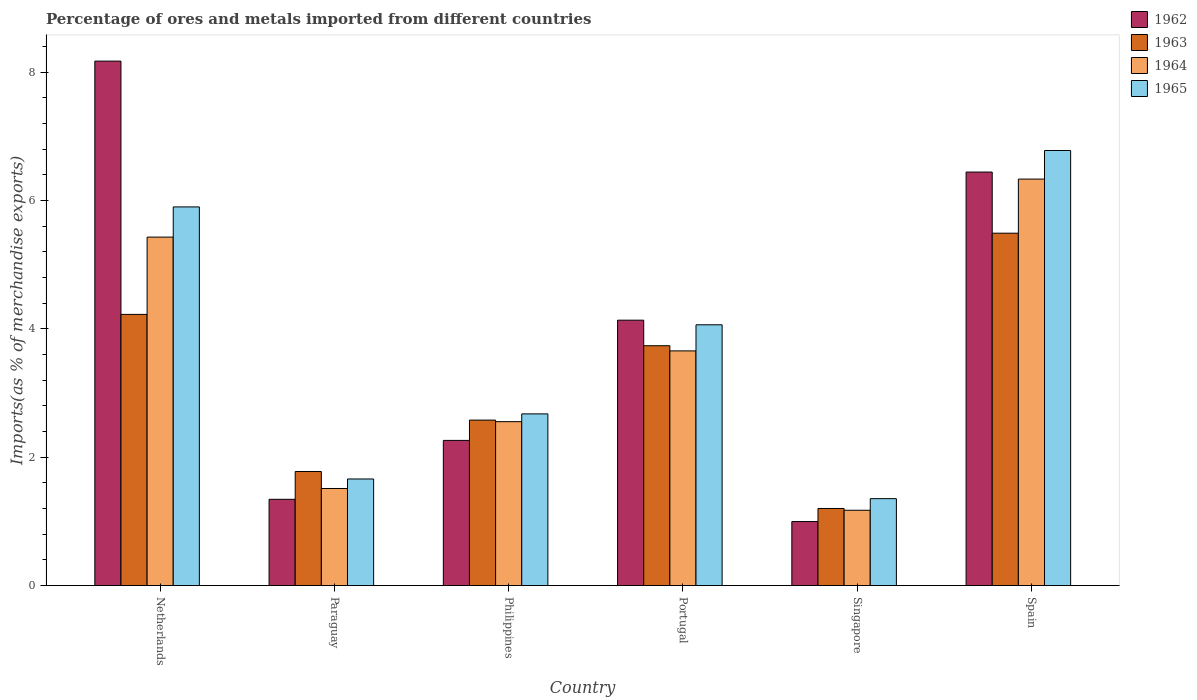How many groups of bars are there?
Make the answer very short. 6. Are the number of bars on each tick of the X-axis equal?
Offer a very short reply. Yes. How many bars are there on the 4th tick from the left?
Give a very brief answer. 4. How many bars are there on the 4th tick from the right?
Provide a succinct answer. 4. What is the percentage of imports to different countries in 1962 in Netherlands?
Make the answer very short. 8.17. Across all countries, what is the maximum percentage of imports to different countries in 1965?
Offer a terse response. 6.78. Across all countries, what is the minimum percentage of imports to different countries in 1962?
Your answer should be compact. 1. In which country was the percentage of imports to different countries in 1962 maximum?
Offer a terse response. Netherlands. In which country was the percentage of imports to different countries in 1963 minimum?
Your answer should be compact. Singapore. What is the total percentage of imports to different countries in 1965 in the graph?
Give a very brief answer. 22.43. What is the difference between the percentage of imports to different countries in 1962 in Netherlands and that in Singapore?
Offer a terse response. 7.17. What is the difference between the percentage of imports to different countries in 1964 in Paraguay and the percentage of imports to different countries in 1962 in Portugal?
Your answer should be compact. -2.62. What is the average percentage of imports to different countries in 1963 per country?
Your response must be concise. 3.17. What is the difference between the percentage of imports to different countries of/in 1962 and percentage of imports to different countries of/in 1963 in Paraguay?
Provide a succinct answer. -0.43. In how many countries, is the percentage of imports to different countries in 1964 greater than 5.6 %?
Your answer should be very brief. 1. What is the ratio of the percentage of imports to different countries in 1964 in Netherlands to that in Singapore?
Offer a terse response. 4.63. Is the percentage of imports to different countries in 1963 in Portugal less than that in Singapore?
Your answer should be compact. No. What is the difference between the highest and the second highest percentage of imports to different countries in 1964?
Ensure brevity in your answer.  -1.77. What is the difference between the highest and the lowest percentage of imports to different countries in 1965?
Ensure brevity in your answer.  5.42. What does the 3rd bar from the left in Netherlands represents?
Your response must be concise. 1964. What does the 2nd bar from the right in Paraguay represents?
Your response must be concise. 1964. What is the difference between two consecutive major ticks on the Y-axis?
Give a very brief answer. 2. Does the graph contain grids?
Keep it short and to the point. No. How many legend labels are there?
Offer a terse response. 4. What is the title of the graph?
Give a very brief answer. Percentage of ores and metals imported from different countries. Does "2000" appear as one of the legend labels in the graph?
Ensure brevity in your answer.  No. What is the label or title of the X-axis?
Your answer should be very brief. Country. What is the label or title of the Y-axis?
Offer a very short reply. Imports(as % of merchandise exports). What is the Imports(as % of merchandise exports) of 1962 in Netherlands?
Give a very brief answer. 8.17. What is the Imports(as % of merchandise exports) in 1963 in Netherlands?
Give a very brief answer. 4.22. What is the Imports(as % of merchandise exports) in 1964 in Netherlands?
Your answer should be compact. 5.43. What is the Imports(as % of merchandise exports) in 1965 in Netherlands?
Provide a succinct answer. 5.9. What is the Imports(as % of merchandise exports) of 1962 in Paraguay?
Give a very brief answer. 1.34. What is the Imports(as % of merchandise exports) in 1963 in Paraguay?
Give a very brief answer. 1.78. What is the Imports(as % of merchandise exports) in 1964 in Paraguay?
Your response must be concise. 1.51. What is the Imports(as % of merchandise exports) of 1965 in Paraguay?
Provide a short and direct response. 1.66. What is the Imports(as % of merchandise exports) in 1962 in Philippines?
Your response must be concise. 2.26. What is the Imports(as % of merchandise exports) of 1963 in Philippines?
Your answer should be very brief. 2.58. What is the Imports(as % of merchandise exports) in 1964 in Philippines?
Provide a short and direct response. 2.55. What is the Imports(as % of merchandise exports) of 1965 in Philippines?
Make the answer very short. 2.67. What is the Imports(as % of merchandise exports) of 1962 in Portugal?
Make the answer very short. 4.13. What is the Imports(as % of merchandise exports) of 1963 in Portugal?
Ensure brevity in your answer.  3.74. What is the Imports(as % of merchandise exports) in 1964 in Portugal?
Ensure brevity in your answer.  3.66. What is the Imports(as % of merchandise exports) in 1965 in Portugal?
Provide a short and direct response. 4.06. What is the Imports(as % of merchandise exports) in 1962 in Singapore?
Offer a terse response. 1. What is the Imports(as % of merchandise exports) of 1963 in Singapore?
Provide a succinct answer. 1.2. What is the Imports(as % of merchandise exports) in 1964 in Singapore?
Give a very brief answer. 1.17. What is the Imports(as % of merchandise exports) of 1965 in Singapore?
Provide a succinct answer. 1.35. What is the Imports(as % of merchandise exports) of 1962 in Spain?
Keep it short and to the point. 6.44. What is the Imports(as % of merchandise exports) in 1963 in Spain?
Make the answer very short. 5.49. What is the Imports(as % of merchandise exports) of 1964 in Spain?
Offer a terse response. 6.33. What is the Imports(as % of merchandise exports) in 1965 in Spain?
Your answer should be very brief. 6.78. Across all countries, what is the maximum Imports(as % of merchandise exports) in 1962?
Your answer should be compact. 8.17. Across all countries, what is the maximum Imports(as % of merchandise exports) in 1963?
Keep it short and to the point. 5.49. Across all countries, what is the maximum Imports(as % of merchandise exports) of 1964?
Your response must be concise. 6.33. Across all countries, what is the maximum Imports(as % of merchandise exports) of 1965?
Ensure brevity in your answer.  6.78. Across all countries, what is the minimum Imports(as % of merchandise exports) in 1962?
Provide a succinct answer. 1. Across all countries, what is the minimum Imports(as % of merchandise exports) in 1963?
Your response must be concise. 1.2. Across all countries, what is the minimum Imports(as % of merchandise exports) of 1964?
Make the answer very short. 1.17. Across all countries, what is the minimum Imports(as % of merchandise exports) in 1965?
Your answer should be compact. 1.35. What is the total Imports(as % of merchandise exports) in 1962 in the graph?
Ensure brevity in your answer.  23.35. What is the total Imports(as % of merchandise exports) of 1963 in the graph?
Your answer should be very brief. 19.01. What is the total Imports(as % of merchandise exports) of 1964 in the graph?
Your response must be concise. 20.66. What is the total Imports(as % of merchandise exports) of 1965 in the graph?
Make the answer very short. 22.43. What is the difference between the Imports(as % of merchandise exports) of 1962 in Netherlands and that in Paraguay?
Offer a very short reply. 6.83. What is the difference between the Imports(as % of merchandise exports) in 1963 in Netherlands and that in Paraguay?
Your answer should be compact. 2.45. What is the difference between the Imports(as % of merchandise exports) of 1964 in Netherlands and that in Paraguay?
Your response must be concise. 3.92. What is the difference between the Imports(as % of merchandise exports) in 1965 in Netherlands and that in Paraguay?
Your answer should be compact. 4.24. What is the difference between the Imports(as % of merchandise exports) in 1962 in Netherlands and that in Philippines?
Make the answer very short. 5.91. What is the difference between the Imports(as % of merchandise exports) in 1963 in Netherlands and that in Philippines?
Offer a terse response. 1.65. What is the difference between the Imports(as % of merchandise exports) in 1964 in Netherlands and that in Philippines?
Ensure brevity in your answer.  2.88. What is the difference between the Imports(as % of merchandise exports) of 1965 in Netherlands and that in Philippines?
Your response must be concise. 3.22. What is the difference between the Imports(as % of merchandise exports) in 1962 in Netherlands and that in Portugal?
Provide a short and direct response. 4.04. What is the difference between the Imports(as % of merchandise exports) in 1963 in Netherlands and that in Portugal?
Provide a succinct answer. 0.49. What is the difference between the Imports(as % of merchandise exports) of 1964 in Netherlands and that in Portugal?
Offer a terse response. 1.77. What is the difference between the Imports(as % of merchandise exports) in 1965 in Netherlands and that in Portugal?
Your response must be concise. 1.84. What is the difference between the Imports(as % of merchandise exports) in 1962 in Netherlands and that in Singapore?
Give a very brief answer. 7.17. What is the difference between the Imports(as % of merchandise exports) of 1963 in Netherlands and that in Singapore?
Give a very brief answer. 3.02. What is the difference between the Imports(as % of merchandise exports) in 1964 in Netherlands and that in Singapore?
Provide a succinct answer. 4.26. What is the difference between the Imports(as % of merchandise exports) of 1965 in Netherlands and that in Singapore?
Your response must be concise. 4.55. What is the difference between the Imports(as % of merchandise exports) in 1962 in Netherlands and that in Spain?
Your answer should be compact. 1.73. What is the difference between the Imports(as % of merchandise exports) of 1963 in Netherlands and that in Spain?
Provide a succinct answer. -1.27. What is the difference between the Imports(as % of merchandise exports) of 1964 in Netherlands and that in Spain?
Your answer should be compact. -0.9. What is the difference between the Imports(as % of merchandise exports) of 1965 in Netherlands and that in Spain?
Provide a short and direct response. -0.88. What is the difference between the Imports(as % of merchandise exports) in 1962 in Paraguay and that in Philippines?
Give a very brief answer. -0.92. What is the difference between the Imports(as % of merchandise exports) in 1963 in Paraguay and that in Philippines?
Your answer should be very brief. -0.8. What is the difference between the Imports(as % of merchandise exports) of 1964 in Paraguay and that in Philippines?
Your answer should be very brief. -1.04. What is the difference between the Imports(as % of merchandise exports) in 1965 in Paraguay and that in Philippines?
Your answer should be very brief. -1.01. What is the difference between the Imports(as % of merchandise exports) of 1962 in Paraguay and that in Portugal?
Provide a short and direct response. -2.79. What is the difference between the Imports(as % of merchandise exports) in 1963 in Paraguay and that in Portugal?
Make the answer very short. -1.96. What is the difference between the Imports(as % of merchandise exports) in 1964 in Paraguay and that in Portugal?
Provide a succinct answer. -2.14. What is the difference between the Imports(as % of merchandise exports) of 1965 in Paraguay and that in Portugal?
Your answer should be compact. -2.4. What is the difference between the Imports(as % of merchandise exports) in 1962 in Paraguay and that in Singapore?
Keep it short and to the point. 0.35. What is the difference between the Imports(as % of merchandise exports) in 1963 in Paraguay and that in Singapore?
Make the answer very short. 0.58. What is the difference between the Imports(as % of merchandise exports) of 1964 in Paraguay and that in Singapore?
Provide a short and direct response. 0.34. What is the difference between the Imports(as % of merchandise exports) of 1965 in Paraguay and that in Singapore?
Give a very brief answer. 0.31. What is the difference between the Imports(as % of merchandise exports) of 1962 in Paraguay and that in Spain?
Provide a succinct answer. -5.1. What is the difference between the Imports(as % of merchandise exports) of 1963 in Paraguay and that in Spain?
Provide a short and direct response. -3.71. What is the difference between the Imports(as % of merchandise exports) of 1964 in Paraguay and that in Spain?
Offer a terse response. -4.82. What is the difference between the Imports(as % of merchandise exports) in 1965 in Paraguay and that in Spain?
Provide a succinct answer. -5.12. What is the difference between the Imports(as % of merchandise exports) in 1962 in Philippines and that in Portugal?
Keep it short and to the point. -1.87. What is the difference between the Imports(as % of merchandise exports) of 1963 in Philippines and that in Portugal?
Provide a short and direct response. -1.16. What is the difference between the Imports(as % of merchandise exports) in 1964 in Philippines and that in Portugal?
Offer a terse response. -1.1. What is the difference between the Imports(as % of merchandise exports) in 1965 in Philippines and that in Portugal?
Offer a very short reply. -1.39. What is the difference between the Imports(as % of merchandise exports) in 1962 in Philippines and that in Singapore?
Offer a terse response. 1.26. What is the difference between the Imports(as % of merchandise exports) in 1963 in Philippines and that in Singapore?
Make the answer very short. 1.38. What is the difference between the Imports(as % of merchandise exports) in 1964 in Philippines and that in Singapore?
Your answer should be compact. 1.38. What is the difference between the Imports(as % of merchandise exports) of 1965 in Philippines and that in Singapore?
Offer a very short reply. 1.32. What is the difference between the Imports(as % of merchandise exports) of 1962 in Philippines and that in Spain?
Your answer should be very brief. -4.18. What is the difference between the Imports(as % of merchandise exports) of 1963 in Philippines and that in Spain?
Provide a succinct answer. -2.91. What is the difference between the Imports(as % of merchandise exports) of 1964 in Philippines and that in Spain?
Give a very brief answer. -3.78. What is the difference between the Imports(as % of merchandise exports) of 1965 in Philippines and that in Spain?
Provide a short and direct response. -4.1. What is the difference between the Imports(as % of merchandise exports) of 1962 in Portugal and that in Singapore?
Your answer should be very brief. 3.14. What is the difference between the Imports(as % of merchandise exports) of 1963 in Portugal and that in Singapore?
Offer a terse response. 2.54. What is the difference between the Imports(as % of merchandise exports) of 1964 in Portugal and that in Singapore?
Provide a succinct answer. 2.48. What is the difference between the Imports(as % of merchandise exports) in 1965 in Portugal and that in Singapore?
Offer a terse response. 2.71. What is the difference between the Imports(as % of merchandise exports) of 1962 in Portugal and that in Spain?
Offer a terse response. -2.31. What is the difference between the Imports(as % of merchandise exports) of 1963 in Portugal and that in Spain?
Your response must be concise. -1.75. What is the difference between the Imports(as % of merchandise exports) in 1964 in Portugal and that in Spain?
Provide a succinct answer. -2.68. What is the difference between the Imports(as % of merchandise exports) of 1965 in Portugal and that in Spain?
Ensure brevity in your answer.  -2.72. What is the difference between the Imports(as % of merchandise exports) in 1962 in Singapore and that in Spain?
Your answer should be compact. -5.45. What is the difference between the Imports(as % of merchandise exports) of 1963 in Singapore and that in Spain?
Your response must be concise. -4.29. What is the difference between the Imports(as % of merchandise exports) of 1964 in Singapore and that in Spain?
Give a very brief answer. -5.16. What is the difference between the Imports(as % of merchandise exports) of 1965 in Singapore and that in Spain?
Your answer should be compact. -5.42. What is the difference between the Imports(as % of merchandise exports) of 1962 in Netherlands and the Imports(as % of merchandise exports) of 1963 in Paraguay?
Your answer should be very brief. 6.39. What is the difference between the Imports(as % of merchandise exports) in 1962 in Netherlands and the Imports(as % of merchandise exports) in 1964 in Paraguay?
Make the answer very short. 6.66. What is the difference between the Imports(as % of merchandise exports) in 1962 in Netherlands and the Imports(as % of merchandise exports) in 1965 in Paraguay?
Provide a short and direct response. 6.51. What is the difference between the Imports(as % of merchandise exports) of 1963 in Netherlands and the Imports(as % of merchandise exports) of 1964 in Paraguay?
Your answer should be very brief. 2.71. What is the difference between the Imports(as % of merchandise exports) in 1963 in Netherlands and the Imports(as % of merchandise exports) in 1965 in Paraguay?
Make the answer very short. 2.56. What is the difference between the Imports(as % of merchandise exports) of 1964 in Netherlands and the Imports(as % of merchandise exports) of 1965 in Paraguay?
Keep it short and to the point. 3.77. What is the difference between the Imports(as % of merchandise exports) of 1962 in Netherlands and the Imports(as % of merchandise exports) of 1963 in Philippines?
Keep it short and to the point. 5.59. What is the difference between the Imports(as % of merchandise exports) of 1962 in Netherlands and the Imports(as % of merchandise exports) of 1964 in Philippines?
Your response must be concise. 5.62. What is the difference between the Imports(as % of merchandise exports) of 1962 in Netherlands and the Imports(as % of merchandise exports) of 1965 in Philippines?
Offer a terse response. 5.5. What is the difference between the Imports(as % of merchandise exports) of 1963 in Netherlands and the Imports(as % of merchandise exports) of 1964 in Philippines?
Provide a short and direct response. 1.67. What is the difference between the Imports(as % of merchandise exports) in 1963 in Netherlands and the Imports(as % of merchandise exports) in 1965 in Philippines?
Your answer should be compact. 1.55. What is the difference between the Imports(as % of merchandise exports) of 1964 in Netherlands and the Imports(as % of merchandise exports) of 1965 in Philippines?
Provide a short and direct response. 2.75. What is the difference between the Imports(as % of merchandise exports) of 1962 in Netherlands and the Imports(as % of merchandise exports) of 1963 in Portugal?
Your answer should be compact. 4.43. What is the difference between the Imports(as % of merchandise exports) of 1962 in Netherlands and the Imports(as % of merchandise exports) of 1964 in Portugal?
Provide a succinct answer. 4.51. What is the difference between the Imports(as % of merchandise exports) in 1962 in Netherlands and the Imports(as % of merchandise exports) in 1965 in Portugal?
Make the answer very short. 4.11. What is the difference between the Imports(as % of merchandise exports) of 1963 in Netherlands and the Imports(as % of merchandise exports) of 1964 in Portugal?
Offer a terse response. 0.57. What is the difference between the Imports(as % of merchandise exports) in 1963 in Netherlands and the Imports(as % of merchandise exports) in 1965 in Portugal?
Offer a terse response. 0.16. What is the difference between the Imports(as % of merchandise exports) of 1964 in Netherlands and the Imports(as % of merchandise exports) of 1965 in Portugal?
Your answer should be very brief. 1.37. What is the difference between the Imports(as % of merchandise exports) in 1962 in Netherlands and the Imports(as % of merchandise exports) in 1963 in Singapore?
Your response must be concise. 6.97. What is the difference between the Imports(as % of merchandise exports) of 1962 in Netherlands and the Imports(as % of merchandise exports) of 1964 in Singapore?
Make the answer very short. 7. What is the difference between the Imports(as % of merchandise exports) in 1962 in Netherlands and the Imports(as % of merchandise exports) in 1965 in Singapore?
Your answer should be compact. 6.82. What is the difference between the Imports(as % of merchandise exports) of 1963 in Netherlands and the Imports(as % of merchandise exports) of 1964 in Singapore?
Your response must be concise. 3.05. What is the difference between the Imports(as % of merchandise exports) of 1963 in Netherlands and the Imports(as % of merchandise exports) of 1965 in Singapore?
Your answer should be compact. 2.87. What is the difference between the Imports(as % of merchandise exports) in 1964 in Netherlands and the Imports(as % of merchandise exports) in 1965 in Singapore?
Provide a short and direct response. 4.07. What is the difference between the Imports(as % of merchandise exports) in 1962 in Netherlands and the Imports(as % of merchandise exports) in 1963 in Spain?
Your answer should be compact. 2.68. What is the difference between the Imports(as % of merchandise exports) in 1962 in Netherlands and the Imports(as % of merchandise exports) in 1964 in Spain?
Your response must be concise. 1.84. What is the difference between the Imports(as % of merchandise exports) in 1962 in Netherlands and the Imports(as % of merchandise exports) in 1965 in Spain?
Give a very brief answer. 1.39. What is the difference between the Imports(as % of merchandise exports) in 1963 in Netherlands and the Imports(as % of merchandise exports) in 1964 in Spain?
Your answer should be compact. -2.11. What is the difference between the Imports(as % of merchandise exports) in 1963 in Netherlands and the Imports(as % of merchandise exports) in 1965 in Spain?
Make the answer very short. -2.55. What is the difference between the Imports(as % of merchandise exports) in 1964 in Netherlands and the Imports(as % of merchandise exports) in 1965 in Spain?
Provide a short and direct response. -1.35. What is the difference between the Imports(as % of merchandise exports) in 1962 in Paraguay and the Imports(as % of merchandise exports) in 1963 in Philippines?
Your response must be concise. -1.23. What is the difference between the Imports(as % of merchandise exports) of 1962 in Paraguay and the Imports(as % of merchandise exports) of 1964 in Philippines?
Your answer should be compact. -1.21. What is the difference between the Imports(as % of merchandise exports) of 1962 in Paraguay and the Imports(as % of merchandise exports) of 1965 in Philippines?
Make the answer very short. -1.33. What is the difference between the Imports(as % of merchandise exports) in 1963 in Paraguay and the Imports(as % of merchandise exports) in 1964 in Philippines?
Provide a succinct answer. -0.78. What is the difference between the Imports(as % of merchandise exports) in 1963 in Paraguay and the Imports(as % of merchandise exports) in 1965 in Philippines?
Ensure brevity in your answer.  -0.9. What is the difference between the Imports(as % of merchandise exports) in 1964 in Paraguay and the Imports(as % of merchandise exports) in 1965 in Philippines?
Keep it short and to the point. -1.16. What is the difference between the Imports(as % of merchandise exports) in 1962 in Paraguay and the Imports(as % of merchandise exports) in 1963 in Portugal?
Your response must be concise. -2.39. What is the difference between the Imports(as % of merchandise exports) of 1962 in Paraguay and the Imports(as % of merchandise exports) of 1964 in Portugal?
Ensure brevity in your answer.  -2.31. What is the difference between the Imports(as % of merchandise exports) in 1962 in Paraguay and the Imports(as % of merchandise exports) in 1965 in Portugal?
Provide a short and direct response. -2.72. What is the difference between the Imports(as % of merchandise exports) of 1963 in Paraguay and the Imports(as % of merchandise exports) of 1964 in Portugal?
Your answer should be compact. -1.88. What is the difference between the Imports(as % of merchandise exports) of 1963 in Paraguay and the Imports(as % of merchandise exports) of 1965 in Portugal?
Provide a short and direct response. -2.29. What is the difference between the Imports(as % of merchandise exports) of 1964 in Paraguay and the Imports(as % of merchandise exports) of 1965 in Portugal?
Your answer should be very brief. -2.55. What is the difference between the Imports(as % of merchandise exports) of 1962 in Paraguay and the Imports(as % of merchandise exports) of 1963 in Singapore?
Your response must be concise. 0.14. What is the difference between the Imports(as % of merchandise exports) in 1962 in Paraguay and the Imports(as % of merchandise exports) in 1964 in Singapore?
Your answer should be compact. 0.17. What is the difference between the Imports(as % of merchandise exports) of 1962 in Paraguay and the Imports(as % of merchandise exports) of 1965 in Singapore?
Make the answer very short. -0.01. What is the difference between the Imports(as % of merchandise exports) of 1963 in Paraguay and the Imports(as % of merchandise exports) of 1964 in Singapore?
Offer a very short reply. 0.6. What is the difference between the Imports(as % of merchandise exports) of 1963 in Paraguay and the Imports(as % of merchandise exports) of 1965 in Singapore?
Offer a terse response. 0.42. What is the difference between the Imports(as % of merchandise exports) in 1964 in Paraguay and the Imports(as % of merchandise exports) in 1965 in Singapore?
Your answer should be very brief. 0.16. What is the difference between the Imports(as % of merchandise exports) in 1962 in Paraguay and the Imports(as % of merchandise exports) in 1963 in Spain?
Keep it short and to the point. -4.15. What is the difference between the Imports(as % of merchandise exports) of 1962 in Paraguay and the Imports(as % of merchandise exports) of 1964 in Spain?
Make the answer very short. -4.99. What is the difference between the Imports(as % of merchandise exports) of 1962 in Paraguay and the Imports(as % of merchandise exports) of 1965 in Spain?
Ensure brevity in your answer.  -5.43. What is the difference between the Imports(as % of merchandise exports) in 1963 in Paraguay and the Imports(as % of merchandise exports) in 1964 in Spain?
Your response must be concise. -4.56. What is the difference between the Imports(as % of merchandise exports) of 1963 in Paraguay and the Imports(as % of merchandise exports) of 1965 in Spain?
Offer a very short reply. -5. What is the difference between the Imports(as % of merchandise exports) of 1964 in Paraguay and the Imports(as % of merchandise exports) of 1965 in Spain?
Your answer should be compact. -5.27. What is the difference between the Imports(as % of merchandise exports) of 1962 in Philippines and the Imports(as % of merchandise exports) of 1963 in Portugal?
Provide a short and direct response. -1.47. What is the difference between the Imports(as % of merchandise exports) in 1962 in Philippines and the Imports(as % of merchandise exports) in 1964 in Portugal?
Provide a short and direct response. -1.39. What is the difference between the Imports(as % of merchandise exports) of 1962 in Philippines and the Imports(as % of merchandise exports) of 1965 in Portugal?
Offer a terse response. -1.8. What is the difference between the Imports(as % of merchandise exports) in 1963 in Philippines and the Imports(as % of merchandise exports) in 1964 in Portugal?
Keep it short and to the point. -1.08. What is the difference between the Imports(as % of merchandise exports) in 1963 in Philippines and the Imports(as % of merchandise exports) in 1965 in Portugal?
Give a very brief answer. -1.48. What is the difference between the Imports(as % of merchandise exports) in 1964 in Philippines and the Imports(as % of merchandise exports) in 1965 in Portugal?
Your response must be concise. -1.51. What is the difference between the Imports(as % of merchandise exports) of 1962 in Philippines and the Imports(as % of merchandise exports) of 1963 in Singapore?
Offer a terse response. 1.06. What is the difference between the Imports(as % of merchandise exports) of 1962 in Philippines and the Imports(as % of merchandise exports) of 1964 in Singapore?
Your answer should be very brief. 1.09. What is the difference between the Imports(as % of merchandise exports) in 1962 in Philippines and the Imports(as % of merchandise exports) in 1965 in Singapore?
Your response must be concise. 0.91. What is the difference between the Imports(as % of merchandise exports) in 1963 in Philippines and the Imports(as % of merchandise exports) in 1964 in Singapore?
Make the answer very short. 1.4. What is the difference between the Imports(as % of merchandise exports) of 1963 in Philippines and the Imports(as % of merchandise exports) of 1965 in Singapore?
Your response must be concise. 1.22. What is the difference between the Imports(as % of merchandise exports) of 1964 in Philippines and the Imports(as % of merchandise exports) of 1965 in Singapore?
Provide a succinct answer. 1.2. What is the difference between the Imports(as % of merchandise exports) in 1962 in Philippines and the Imports(as % of merchandise exports) in 1963 in Spain?
Give a very brief answer. -3.23. What is the difference between the Imports(as % of merchandise exports) in 1962 in Philippines and the Imports(as % of merchandise exports) in 1964 in Spain?
Keep it short and to the point. -4.07. What is the difference between the Imports(as % of merchandise exports) of 1962 in Philippines and the Imports(as % of merchandise exports) of 1965 in Spain?
Make the answer very short. -4.52. What is the difference between the Imports(as % of merchandise exports) in 1963 in Philippines and the Imports(as % of merchandise exports) in 1964 in Spain?
Provide a succinct answer. -3.75. What is the difference between the Imports(as % of merchandise exports) in 1963 in Philippines and the Imports(as % of merchandise exports) in 1965 in Spain?
Ensure brevity in your answer.  -4.2. What is the difference between the Imports(as % of merchandise exports) of 1964 in Philippines and the Imports(as % of merchandise exports) of 1965 in Spain?
Keep it short and to the point. -4.22. What is the difference between the Imports(as % of merchandise exports) in 1962 in Portugal and the Imports(as % of merchandise exports) in 1963 in Singapore?
Provide a succinct answer. 2.93. What is the difference between the Imports(as % of merchandise exports) in 1962 in Portugal and the Imports(as % of merchandise exports) in 1964 in Singapore?
Your answer should be very brief. 2.96. What is the difference between the Imports(as % of merchandise exports) of 1962 in Portugal and the Imports(as % of merchandise exports) of 1965 in Singapore?
Make the answer very short. 2.78. What is the difference between the Imports(as % of merchandise exports) of 1963 in Portugal and the Imports(as % of merchandise exports) of 1964 in Singapore?
Your response must be concise. 2.56. What is the difference between the Imports(as % of merchandise exports) in 1963 in Portugal and the Imports(as % of merchandise exports) in 1965 in Singapore?
Provide a short and direct response. 2.38. What is the difference between the Imports(as % of merchandise exports) in 1964 in Portugal and the Imports(as % of merchandise exports) in 1965 in Singapore?
Offer a very short reply. 2.3. What is the difference between the Imports(as % of merchandise exports) in 1962 in Portugal and the Imports(as % of merchandise exports) in 1963 in Spain?
Provide a short and direct response. -1.36. What is the difference between the Imports(as % of merchandise exports) in 1962 in Portugal and the Imports(as % of merchandise exports) in 1964 in Spain?
Your response must be concise. -2.2. What is the difference between the Imports(as % of merchandise exports) in 1962 in Portugal and the Imports(as % of merchandise exports) in 1965 in Spain?
Your answer should be compact. -2.64. What is the difference between the Imports(as % of merchandise exports) of 1963 in Portugal and the Imports(as % of merchandise exports) of 1964 in Spain?
Your answer should be compact. -2.6. What is the difference between the Imports(as % of merchandise exports) of 1963 in Portugal and the Imports(as % of merchandise exports) of 1965 in Spain?
Make the answer very short. -3.04. What is the difference between the Imports(as % of merchandise exports) of 1964 in Portugal and the Imports(as % of merchandise exports) of 1965 in Spain?
Make the answer very short. -3.12. What is the difference between the Imports(as % of merchandise exports) in 1962 in Singapore and the Imports(as % of merchandise exports) in 1963 in Spain?
Provide a short and direct response. -4.49. What is the difference between the Imports(as % of merchandise exports) in 1962 in Singapore and the Imports(as % of merchandise exports) in 1964 in Spain?
Provide a succinct answer. -5.34. What is the difference between the Imports(as % of merchandise exports) in 1962 in Singapore and the Imports(as % of merchandise exports) in 1965 in Spain?
Keep it short and to the point. -5.78. What is the difference between the Imports(as % of merchandise exports) of 1963 in Singapore and the Imports(as % of merchandise exports) of 1964 in Spain?
Make the answer very short. -5.13. What is the difference between the Imports(as % of merchandise exports) in 1963 in Singapore and the Imports(as % of merchandise exports) in 1965 in Spain?
Give a very brief answer. -5.58. What is the difference between the Imports(as % of merchandise exports) of 1964 in Singapore and the Imports(as % of merchandise exports) of 1965 in Spain?
Your answer should be very brief. -5.61. What is the average Imports(as % of merchandise exports) of 1962 per country?
Make the answer very short. 3.89. What is the average Imports(as % of merchandise exports) in 1963 per country?
Your answer should be very brief. 3.17. What is the average Imports(as % of merchandise exports) of 1964 per country?
Give a very brief answer. 3.44. What is the average Imports(as % of merchandise exports) in 1965 per country?
Your answer should be very brief. 3.74. What is the difference between the Imports(as % of merchandise exports) in 1962 and Imports(as % of merchandise exports) in 1963 in Netherlands?
Make the answer very short. 3.95. What is the difference between the Imports(as % of merchandise exports) of 1962 and Imports(as % of merchandise exports) of 1964 in Netherlands?
Make the answer very short. 2.74. What is the difference between the Imports(as % of merchandise exports) of 1962 and Imports(as % of merchandise exports) of 1965 in Netherlands?
Provide a short and direct response. 2.27. What is the difference between the Imports(as % of merchandise exports) of 1963 and Imports(as % of merchandise exports) of 1964 in Netherlands?
Provide a short and direct response. -1.2. What is the difference between the Imports(as % of merchandise exports) in 1963 and Imports(as % of merchandise exports) in 1965 in Netherlands?
Ensure brevity in your answer.  -1.67. What is the difference between the Imports(as % of merchandise exports) of 1964 and Imports(as % of merchandise exports) of 1965 in Netherlands?
Ensure brevity in your answer.  -0.47. What is the difference between the Imports(as % of merchandise exports) in 1962 and Imports(as % of merchandise exports) in 1963 in Paraguay?
Offer a terse response. -0.43. What is the difference between the Imports(as % of merchandise exports) in 1962 and Imports(as % of merchandise exports) in 1964 in Paraguay?
Ensure brevity in your answer.  -0.17. What is the difference between the Imports(as % of merchandise exports) in 1962 and Imports(as % of merchandise exports) in 1965 in Paraguay?
Offer a very short reply. -0.32. What is the difference between the Imports(as % of merchandise exports) in 1963 and Imports(as % of merchandise exports) in 1964 in Paraguay?
Make the answer very short. 0.26. What is the difference between the Imports(as % of merchandise exports) of 1963 and Imports(as % of merchandise exports) of 1965 in Paraguay?
Offer a very short reply. 0.12. What is the difference between the Imports(as % of merchandise exports) of 1964 and Imports(as % of merchandise exports) of 1965 in Paraguay?
Provide a short and direct response. -0.15. What is the difference between the Imports(as % of merchandise exports) of 1962 and Imports(as % of merchandise exports) of 1963 in Philippines?
Offer a terse response. -0.32. What is the difference between the Imports(as % of merchandise exports) of 1962 and Imports(as % of merchandise exports) of 1964 in Philippines?
Ensure brevity in your answer.  -0.29. What is the difference between the Imports(as % of merchandise exports) of 1962 and Imports(as % of merchandise exports) of 1965 in Philippines?
Give a very brief answer. -0.41. What is the difference between the Imports(as % of merchandise exports) in 1963 and Imports(as % of merchandise exports) in 1964 in Philippines?
Your answer should be compact. 0.02. What is the difference between the Imports(as % of merchandise exports) of 1963 and Imports(as % of merchandise exports) of 1965 in Philippines?
Provide a succinct answer. -0.1. What is the difference between the Imports(as % of merchandise exports) in 1964 and Imports(as % of merchandise exports) in 1965 in Philippines?
Your answer should be very brief. -0.12. What is the difference between the Imports(as % of merchandise exports) of 1962 and Imports(as % of merchandise exports) of 1963 in Portugal?
Offer a very short reply. 0.4. What is the difference between the Imports(as % of merchandise exports) of 1962 and Imports(as % of merchandise exports) of 1964 in Portugal?
Give a very brief answer. 0.48. What is the difference between the Imports(as % of merchandise exports) in 1962 and Imports(as % of merchandise exports) in 1965 in Portugal?
Provide a succinct answer. 0.07. What is the difference between the Imports(as % of merchandise exports) in 1963 and Imports(as % of merchandise exports) in 1964 in Portugal?
Your answer should be compact. 0.08. What is the difference between the Imports(as % of merchandise exports) in 1963 and Imports(as % of merchandise exports) in 1965 in Portugal?
Provide a succinct answer. -0.33. What is the difference between the Imports(as % of merchandise exports) of 1964 and Imports(as % of merchandise exports) of 1965 in Portugal?
Provide a short and direct response. -0.41. What is the difference between the Imports(as % of merchandise exports) of 1962 and Imports(as % of merchandise exports) of 1963 in Singapore?
Give a very brief answer. -0.2. What is the difference between the Imports(as % of merchandise exports) in 1962 and Imports(as % of merchandise exports) in 1964 in Singapore?
Offer a terse response. -0.18. What is the difference between the Imports(as % of merchandise exports) of 1962 and Imports(as % of merchandise exports) of 1965 in Singapore?
Make the answer very short. -0.36. What is the difference between the Imports(as % of merchandise exports) of 1963 and Imports(as % of merchandise exports) of 1964 in Singapore?
Your response must be concise. 0.03. What is the difference between the Imports(as % of merchandise exports) in 1963 and Imports(as % of merchandise exports) in 1965 in Singapore?
Your answer should be compact. -0.15. What is the difference between the Imports(as % of merchandise exports) of 1964 and Imports(as % of merchandise exports) of 1965 in Singapore?
Keep it short and to the point. -0.18. What is the difference between the Imports(as % of merchandise exports) in 1962 and Imports(as % of merchandise exports) in 1964 in Spain?
Provide a succinct answer. 0.11. What is the difference between the Imports(as % of merchandise exports) of 1962 and Imports(as % of merchandise exports) of 1965 in Spain?
Offer a very short reply. -0.34. What is the difference between the Imports(as % of merchandise exports) in 1963 and Imports(as % of merchandise exports) in 1964 in Spain?
Your answer should be compact. -0.84. What is the difference between the Imports(as % of merchandise exports) in 1963 and Imports(as % of merchandise exports) in 1965 in Spain?
Provide a short and direct response. -1.29. What is the difference between the Imports(as % of merchandise exports) in 1964 and Imports(as % of merchandise exports) in 1965 in Spain?
Offer a terse response. -0.45. What is the ratio of the Imports(as % of merchandise exports) in 1962 in Netherlands to that in Paraguay?
Your response must be concise. 6.08. What is the ratio of the Imports(as % of merchandise exports) in 1963 in Netherlands to that in Paraguay?
Keep it short and to the point. 2.38. What is the ratio of the Imports(as % of merchandise exports) in 1964 in Netherlands to that in Paraguay?
Your response must be concise. 3.59. What is the ratio of the Imports(as % of merchandise exports) in 1965 in Netherlands to that in Paraguay?
Provide a short and direct response. 3.55. What is the ratio of the Imports(as % of merchandise exports) in 1962 in Netherlands to that in Philippines?
Your answer should be compact. 3.61. What is the ratio of the Imports(as % of merchandise exports) in 1963 in Netherlands to that in Philippines?
Ensure brevity in your answer.  1.64. What is the ratio of the Imports(as % of merchandise exports) in 1964 in Netherlands to that in Philippines?
Give a very brief answer. 2.13. What is the ratio of the Imports(as % of merchandise exports) of 1965 in Netherlands to that in Philippines?
Your response must be concise. 2.21. What is the ratio of the Imports(as % of merchandise exports) in 1962 in Netherlands to that in Portugal?
Your response must be concise. 1.98. What is the ratio of the Imports(as % of merchandise exports) in 1963 in Netherlands to that in Portugal?
Ensure brevity in your answer.  1.13. What is the ratio of the Imports(as % of merchandise exports) in 1964 in Netherlands to that in Portugal?
Provide a short and direct response. 1.49. What is the ratio of the Imports(as % of merchandise exports) in 1965 in Netherlands to that in Portugal?
Offer a very short reply. 1.45. What is the ratio of the Imports(as % of merchandise exports) in 1962 in Netherlands to that in Singapore?
Provide a short and direct response. 8.19. What is the ratio of the Imports(as % of merchandise exports) in 1963 in Netherlands to that in Singapore?
Provide a short and direct response. 3.52. What is the ratio of the Imports(as % of merchandise exports) in 1964 in Netherlands to that in Singapore?
Your response must be concise. 4.63. What is the ratio of the Imports(as % of merchandise exports) of 1965 in Netherlands to that in Singapore?
Your answer should be compact. 4.36. What is the ratio of the Imports(as % of merchandise exports) in 1962 in Netherlands to that in Spain?
Offer a very short reply. 1.27. What is the ratio of the Imports(as % of merchandise exports) of 1963 in Netherlands to that in Spain?
Keep it short and to the point. 0.77. What is the ratio of the Imports(as % of merchandise exports) in 1964 in Netherlands to that in Spain?
Make the answer very short. 0.86. What is the ratio of the Imports(as % of merchandise exports) of 1965 in Netherlands to that in Spain?
Ensure brevity in your answer.  0.87. What is the ratio of the Imports(as % of merchandise exports) in 1962 in Paraguay to that in Philippines?
Your answer should be very brief. 0.59. What is the ratio of the Imports(as % of merchandise exports) of 1963 in Paraguay to that in Philippines?
Your response must be concise. 0.69. What is the ratio of the Imports(as % of merchandise exports) of 1964 in Paraguay to that in Philippines?
Give a very brief answer. 0.59. What is the ratio of the Imports(as % of merchandise exports) in 1965 in Paraguay to that in Philippines?
Give a very brief answer. 0.62. What is the ratio of the Imports(as % of merchandise exports) of 1962 in Paraguay to that in Portugal?
Provide a succinct answer. 0.33. What is the ratio of the Imports(as % of merchandise exports) in 1963 in Paraguay to that in Portugal?
Give a very brief answer. 0.48. What is the ratio of the Imports(as % of merchandise exports) of 1964 in Paraguay to that in Portugal?
Keep it short and to the point. 0.41. What is the ratio of the Imports(as % of merchandise exports) in 1965 in Paraguay to that in Portugal?
Make the answer very short. 0.41. What is the ratio of the Imports(as % of merchandise exports) in 1962 in Paraguay to that in Singapore?
Ensure brevity in your answer.  1.35. What is the ratio of the Imports(as % of merchandise exports) in 1963 in Paraguay to that in Singapore?
Your response must be concise. 1.48. What is the ratio of the Imports(as % of merchandise exports) in 1964 in Paraguay to that in Singapore?
Offer a very short reply. 1.29. What is the ratio of the Imports(as % of merchandise exports) of 1965 in Paraguay to that in Singapore?
Offer a terse response. 1.23. What is the ratio of the Imports(as % of merchandise exports) of 1962 in Paraguay to that in Spain?
Your response must be concise. 0.21. What is the ratio of the Imports(as % of merchandise exports) in 1963 in Paraguay to that in Spain?
Give a very brief answer. 0.32. What is the ratio of the Imports(as % of merchandise exports) in 1964 in Paraguay to that in Spain?
Provide a short and direct response. 0.24. What is the ratio of the Imports(as % of merchandise exports) of 1965 in Paraguay to that in Spain?
Ensure brevity in your answer.  0.24. What is the ratio of the Imports(as % of merchandise exports) in 1962 in Philippines to that in Portugal?
Provide a succinct answer. 0.55. What is the ratio of the Imports(as % of merchandise exports) in 1963 in Philippines to that in Portugal?
Your answer should be very brief. 0.69. What is the ratio of the Imports(as % of merchandise exports) in 1964 in Philippines to that in Portugal?
Make the answer very short. 0.7. What is the ratio of the Imports(as % of merchandise exports) in 1965 in Philippines to that in Portugal?
Offer a terse response. 0.66. What is the ratio of the Imports(as % of merchandise exports) of 1962 in Philippines to that in Singapore?
Keep it short and to the point. 2.27. What is the ratio of the Imports(as % of merchandise exports) of 1963 in Philippines to that in Singapore?
Your response must be concise. 2.15. What is the ratio of the Imports(as % of merchandise exports) in 1964 in Philippines to that in Singapore?
Offer a terse response. 2.18. What is the ratio of the Imports(as % of merchandise exports) of 1965 in Philippines to that in Singapore?
Offer a very short reply. 1.98. What is the ratio of the Imports(as % of merchandise exports) of 1962 in Philippines to that in Spain?
Provide a short and direct response. 0.35. What is the ratio of the Imports(as % of merchandise exports) in 1963 in Philippines to that in Spain?
Provide a short and direct response. 0.47. What is the ratio of the Imports(as % of merchandise exports) in 1964 in Philippines to that in Spain?
Ensure brevity in your answer.  0.4. What is the ratio of the Imports(as % of merchandise exports) in 1965 in Philippines to that in Spain?
Ensure brevity in your answer.  0.39. What is the ratio of the Imports(as % of merchandise exports) of 1962 in Portugal to that in Singapore?
Your answer should be very brief. 4.15. What is the ratio of the Imports(as % of merchandise exports) in 1963 in Portugal to that in Singapore?
Ensure brevity in your answer.  3.11. What is the ratio of the Imports(as % of merchandise exports) of 1964 in Portugal to that in Singapore?
Your answer should be compact. 3.12. What is the ratio of the Imports(as % of merchandise exports) of 1965 in Portugal to that in Singapore?
Offer a very short reply. 3. What is the ratio of the Imports(as % of merchandise exports) of 1962 in Portugal to that in Spain?
Ensure brevity in your answer.  0.64. What is the ratio of the Imports(as % of merchandise exports) in 1963 in Portugal to that in Spain?
Offer a terse response. 0.68. What is the ratio of the Imports(as % of merchandise exports) in 1964 in Portugal to that in Spain?
Make the answer very short. 0.58. What is the ratio of the Imports(as % of merchandise exports) in 1965 in Portugal to that in Spain?
Offer a terse response. 0.6. What is the ratio of the Imports(as % of merchandise exports) of 1962 in Singapore to that in Spain?
Your answer should be compact. 0.15. What is the ratio of the Imports(as % of merchandise exports) in 1963 in Singapore to that in Spain?
Your response must be concise. 0.22. What is the ratio of the Imports(as % of merchandise exports) in 1964 in Singapore to that in Spain?
Give a very brief answer. 0.19. What is the ratio of the Imports(as % of merchandise exports) in 1965 in Singapore to that in Spain?
Give a very brief answer. 0.2. What is the difference between the highest and the second highest Imports(as % of merchandise exports) of 1962?
Give a very brief answer. 1.73. What is the difference between the highest and the second highest Imports(as % of merchandise exports) in 1963?
Give a very brief answer. 1.27. What is the difference between the highest and the second highest Imports(as % of merchandise exports) of 1964?
Your answer should be compact. 0.9. What is the difference between the highest and the second highest Imports(as % of merchandise exports) in 1965?
Ensure brevity in your answer.  0.88. What is the difference between the highest and the lowest Imports(as % of merchandise exports) of 1962?
Give a very brief answer. 7.17. What is the difference between the highest and the lowest Imports(as % of merchandise exports) in 1963?
Offer a very short reply. 4.29. What is the difference between the highest and the lowest Imports(as % of merchandise exports) in 1964?
Give a very brief answer. 5.16. What is the difference between the highest and the lowest Imports(as % of merchandise exports) in 1965?
Your response must be concise. 5.42. 